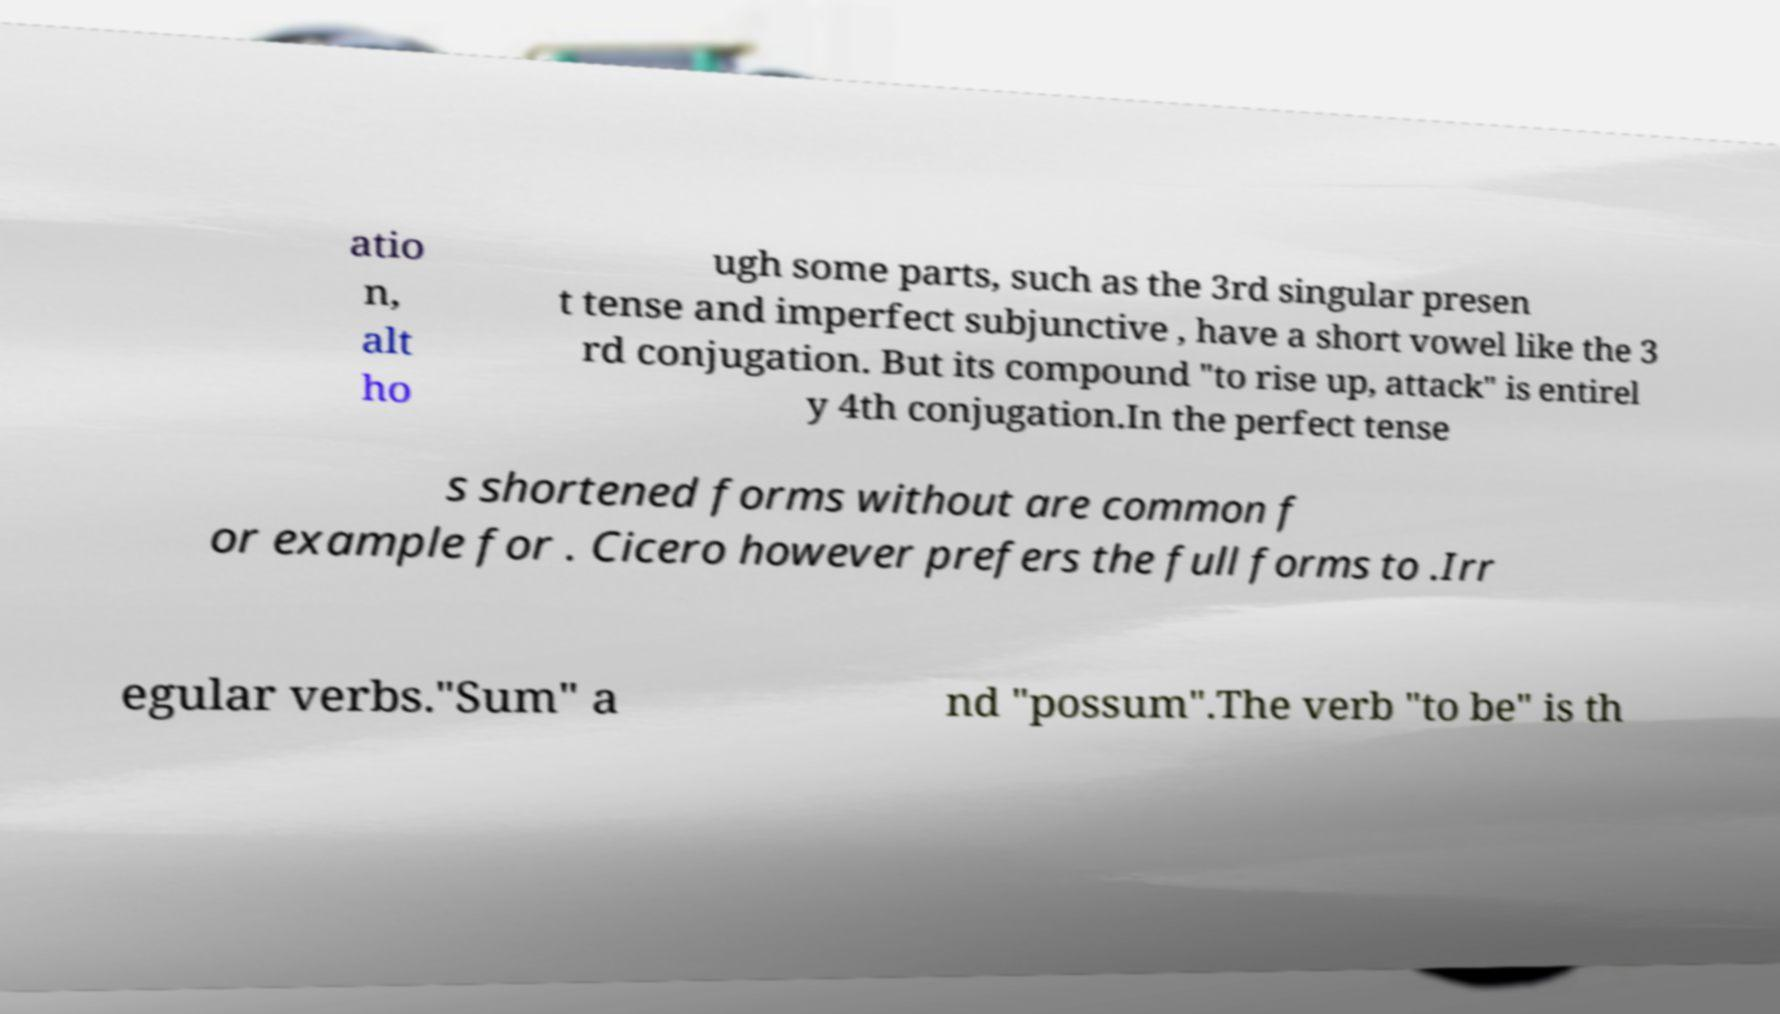What messages or text are displayed in this image? I need them in a readable, typed format. atio n, alt ho ugh some parts, such as the 3rd singular presen t tense and imperfect subjunctive , have a short vowel like the 3 rd conjugation. But its compound "to rise up, attack" is entirel y 4th conjugation.In the perfect tense s shortened forms without are common f or example for . Cicero however prefers the full forms to .Irr egular verbs."Sum" a nd "possum".The verb "to be" is th 